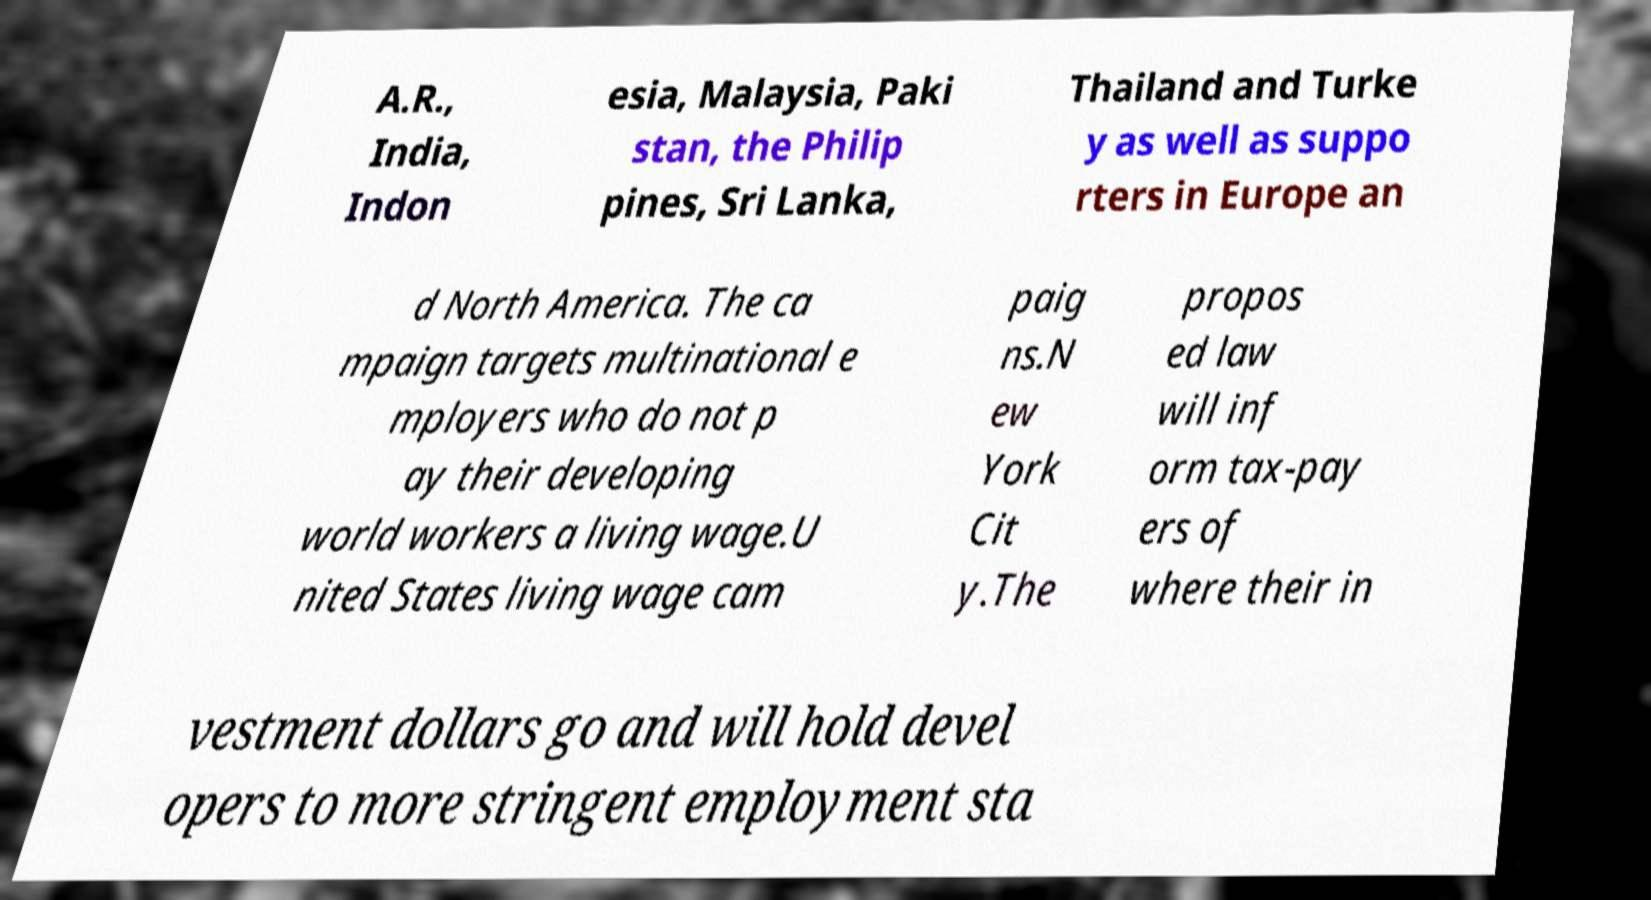Can you read and provide the text displayed in the image?This photo seems to have some interesting text. Can you extract and type it out for me? A.R., India, Indon esia, Malaysia, Paki stan, the Philip pines, Sri Lanka, Thailand and Turke y as well as suppo rters in Europe an d North America. The ca mpaign targets multinational e mployers who do not p ay their developing world workers a living wage.U nited States living wage cam paig ns.N ew York Cit y.The propos ed law will inf orm tax-pay ers of where their in vestment dollars go and will hold devel opers to more stringent employment sta 